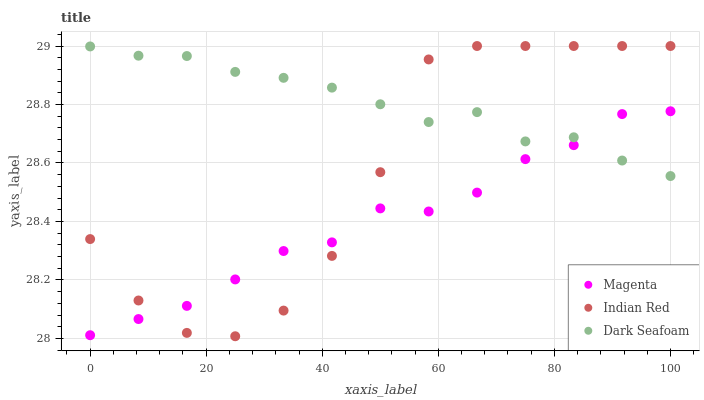Does Magenta have the minimum area under the curve?
Answer yes or no. Yes. Does Dark Seafoam have the maximum area under the curve?
Answer yes or no. Yes. Does Indian Red have the minimum area under the curve?
Answer yes or no. No. Does Indian Red have the maximum area under the curve?
Answer yes or no. No. Is Dark Seafoam the smoothest?
Answer yes or no. Yes. Is Indian Red the roughest?
Answer yes or no. Yes. Is Indian Red the smoothest?
Answer yes or no. No. Is Dark Seafoam the roughest?
Answer yes or no. No. Does Indian Red have the lowest value?
Answer yes or no. Yes. Does Dark Seafoam have the lowest value?
Answer yes or no. No. Does Indian Red have the highest value?
Answer yes or no. Yes. Does Dark Seafoam have the highest value?
Answer yes or no. No. Does Indian Red intersect Magenta?
Answer yes or no. Yes. Is Indian Red less than Magenta?
Answer yes or no. No. Is Indian Red greater than Magenta?
Answer yes or no. No. 